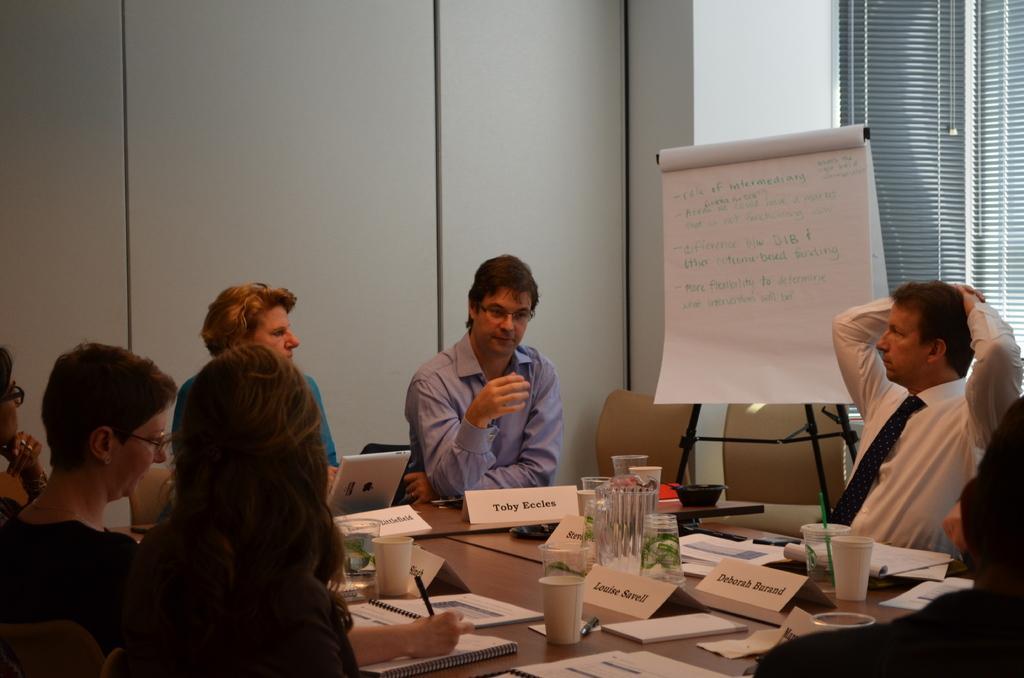Please provide a concise description of this image. A picture inside of a room. This persons are sitting on a chair. In-front of this person there is a table, on a table there are glasses, name boards and laptop. Far this is a whiteboard. This woman is holding a pen. 